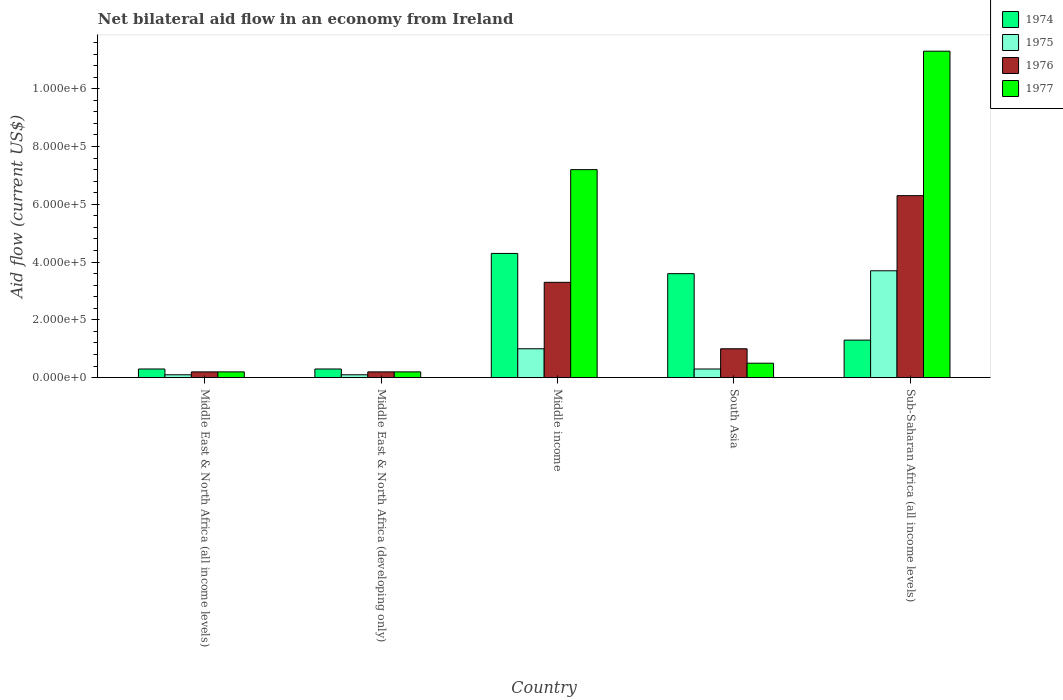How many groups of bars are there?
Your answer should be very brief. 5. How many bars are there on the 4th tick from the left?
Your answer should be very brief. 4. What is the label of the 3rd group of bars from the left?
Your response must be concise. Middle income. What is the net bilateral aid flow in 1977 in Middle East & North Africa (all income levels)?
Provide a succinct answer. 2.00e+04. Across all countries, what is the maximum net bilateral aid flow in 1976?
Offer a very short reply. 6.30e+05. In which country was the net bilateral aid flow in 1976 maximum?
Your answer should be very brief. Sub-Saharan Africa (all income levels). In which country was the net bilateral aid flow in 1975 minimum?
Provide a succinct answer. Middle East & North Africa (all income levels). What is the total net bilateral aid flow in 1974 in the graph?
Give a very brief answer. 9.80e+05. What is the difference between the net bilateral aid flow in 1975 in Middle East & North Africa (all income levels) and that in Middle East & North Africa (developing only)?
Make the answer very short. 0. What is the difference between the net bilateral aid flow in 1977 in Middle East & North Africa (all income levels) and the net bilateral aid flow in 1974 in Middle East & North Africa (developing only)?
Provide a short and direct response. -10000. What is the average net bilateral aid flow in 1974 per country?
Keep it short and to the point. 1.96e+05. What is the difference between the net bilateral aid flow of/in 1975 and net bilateral aid flow of/in 1976 in Middle East & North Africa (all income levels)?
Provide a short and direct response. -10000. In how many countries, is the net bilateral aid flow in 1975 greater than 1040000 US$?
Offer a terse response. 0. What is the ratio of the net bilateral aid flow in 1977 in Middle East & North Africa (all income levels) to that in Middle income?
Ensure brevity in your answer.  0.03. Is the net bilateral aid flow in 1976 in Middle East & North Africa (developing only) less than that in Middle income?
Offer a very short reply. Yes. Is the difference between the net bilateral aid flow in 1975 in South Asia and Sub-Saharan Africa (all income levels) greater than the difference between the net bilateral aid flow in 1976 in South Asia and Sub-Saharan Africa (all income levels)?
Keep it short and to the point. Yes. What is the difference between the highest and the second highest net bilateral aid flow in 1974?
Offer a very short reply. 7.00e+04. What does the 3rd bar from the left in Middle income represents?
Provide a succinct answer. 1976. What does the 3rd bar from the right in Middle East & North Africa (developing only) represents?
Give a very brief answer. 1975. Is it the case that in every country, the sum of the net bilateral aid flow in 1977 and net bilateral aid flow in 1976 is greater than the net bilateral aid flow in 1975?
Give a very brief answer. Yes. How many countries are there in the graph?
Ensure brevity in your answer.  5. What is the difference between two consecutive major ticks on the Y-axis?
Offer a very short reply. 2.00e+05. Does the graph contain any zero values?
Your response must be concise. No. Does the graph contain grids?
Ensure brevity in your answer.  No. How are the legend labels stacked?
Make the answer very short. Vertical. What is the title of the graph?
Offer a very short reply. Net bilateral aid flow in an economy from Ireland. Does "2010" appear as one of the legend labels in the graph?
Provide a short and direct response. No. What is the label or title of the X-axis?
Provide a short and direct response. Country. What is the Aid flow (current US$) in 1974 in Middle East & North Africa (all income levels)?
Provide a succinct answer. 3.00e+04. What is the Aid flow (current US$) in 1976 in Middle East & North Africa (all income levels)?
Offer a very short reply. 2.00e+04. What is the Aid flow (current US$) in 1974 in Middle East & North Africa (developing only)?
Give a very brief answer. 3.00e+04. What is the Aid flow (current US$) of 1976 in Middle East & North Africa (developing only)?
Provide a succinct answer. 2.00e+04. What is the Aid flow (current US$) in 1977 in Middle East & North Africa (developing only)?
Ensure brevity in your answer.  2.00e+04. What is the Aid flow (current US$) in 1975 in Middle income?
Offer a terse response. 1.00e+05. What is the Aid flow (current US$) of 1977 in Middle income?
Offer a terse response. 7.20e+05. What is the Aid flow (current US$) in 1974 in South Asia?
Offer a very short reply. 3.60e+05. What is the Aid flow (current US$) in 1975 in South Asia?
Keep it short and to the point. 3.00e+04. What is the Aid flow (current US$) in 1976 in South Asia?
Your response must be concise. 1.00e+05. What is the Aid flow (current US$) in 1974 in Sub-Saharan Africa (all income levels)?
Give a very brief answer. 1.30e+05. What is the Aid flow (current US$) of 1976 in Sub-Saharan Africa (all income levels)?
Offer a terse response. 6.30e+05. What is the Aid flow (current US$) of 1977 in Sub-Saharan Africa (all income levels)?
Make the answer very short. 1.13e+06. Across all countries, what is the maximum Aid flow (current US$) of 1974?
Ensure brevity in your answer.  4.30e+05. Across all countries, what is the maximum Aid flow (current US$) in 1975?
Your answer should be compact. 3.70e+05. Across all countries, what is the maximum Aid flow (current US$) of 1976?
Offer a terse response. 6.30e+05. Across all countries, what is the maximum Aid flow (current US$) of 1977?
Provide a succinct answer. 1.13e+06. Across all countries, what is the minimum Aid flow (current US$) in 1975?
Your response must be concise. 10000. Across all countries, what is the minimum Aid flow (current US$) in 1976?
Your answer should be compact. 2.00e+04. What is the total Aid flow (current US$) of 1974 in the graph?
Provide a short and direct response. 9.80e+05. What is the total Aid flow (current US$) of 1975 in the graph?
Give a very brief answer. 5.20e+05. What is the total Aid flow (current US$) of 1976 in the graph?
Keep it short and to the point. 1.10e+06. What is the total Aid flow (current US$) in 1977 in the graph?
Make the answer very short. 1.94e+06. What is the difference between the Aid flow (current US$) in 1974 in Middle East & North Africa (all income levels) and that in Middle East & North Africa (developing only)?
Your answer should be very brief. 0. What is the difference between the Aid flow (current US$) in 1975 in Middle East & North Africa (all income levels) and that in Middle East & North Africa (developing only)?
Your answer should be compact. 0. What is the difference between the Aid flow (current US$) of 1976 in Middle East & North Africa (all income levels) and that in Middle East & North Africa (developing only)?
Ensure brevity in your answer.  0. What is the difference between the Aid flow (current US$) of 1977 in Middle East & North Africa (all income levels) and that in Middle East & North Africa (developing only)?
Your response must be concise. 0. What is the difference between the Aid flow (current US$) of 1974 in Middle East & North Africa (all income levels) and that in Middle income?
Provide a short and direct response. -4.00e+05. What is the difference between the Aid flow (current US$) in 1976 in Middle East & North Africa (all income levels) and that in Middle income?
Keep it short and to the point. -3.10e+05. What is the difference between the Aid flow (current US$) in 1977 in Middle East & North Africa (all income levels) and that in Middle income?
Make the answer very short. -7.00e+05. What is the difference between the Aid flow (current US$) in 1974 in Middle East & North Africa (all income levels) and that in South Asia?
Provide a succinct answer. -3.30e+05. What is the difference between the Aid flow (current US$) of 1975 in Middle East & North Africa (all income levels) and that in South Asia?
Provide a succinct answer. -2.00e+04. What is the difference between the Aid flow (current US$) of 1974 in Middle East & North Africa (all income levels) and that in Sub-Saharan Africa (all income levels)?
Provide a short and direct response. -1.00e+05. What is the difference between the Aid flow (current US$) of 1975 in Middle East & North Africa (all income levels) and that in Sub-Saharan Africa (all income levels)?
Offer a terse response. -3.60e+05. What is the difference between the Aid flow (current US$) of 1976 in Middle East & North Africa (all income levels) and that in Sub-Saharan Africa (all income levels)?
Offer a very short reply. -6.10e+05. What is the difference between the Aid flow (current US$) of 1977 in Middle East & North Africa (all income levels) and that in Sub-Saharan Africa (all income levels)?
Provide a short and direct response. -1.11e+06. What is the difference between the Aid flow (current US$) of 1974 in Middle East & North Africa (developing only) and that in Middle income?
Provide a succinct answer. -4.00e+05. What is the difference between the Aid flow (current US$) in 1975 in Middle East & North Africa (developing only) and that in Middle income?
Your response must be concise. -9.00e+04. What is the difference between the Aid flow (current US$) in 1976 in Middle East & North Africa (developing only) and that in Middle income?
Provide a short and direct response. -3.10e+05. What is the difference between the Aid flow (current US$) in 1977 in Middle East & North Africa (developing only) and that in Middle income?
Offer a terse response. -7.00e+05. What is the difference between the Aid flow (current US$) in 1974 in Middle East & North Africa (developing only) and that in South Asia?
Give a very brief answer. -3.30e+05. What is the difference between the Aid flow (current US$) in 1976 in Middle East & North Africa (developing only) and that in South Asia?
Offer a very short reply. -8.00e+04. What is the difference between the Aid flow (current US$) of 1975 in Middle East & North Africa (developing only) and that in Sub-Saharan Africa (all income levels)?
Your answer should be very brief. -3.60e+05. What is the difference between the Aid flow (current US$) of 1976 in Middle East & North Africa (developing only) and that in Sub-Saharan Africa (all income levels)?
Give a very brief answer. -6.10e+05. What is the difference between the Aid flow (current US$) in 1977 in Middle East & North Africa (developing only) and that in Sub-Saharan Africa (all income levels)?
Provide a succinct answer. -1.11e+06. What is the difference between the Aid flow (current US$) of 1975 in Middle income and that in South Asia?
Make the answer very short. 7.00e+04. What is the difference between the Aid flow (current US$) of 1977 in Middle income and that in South Asia?
Ensure brevity in your answer.  6.70e+05. What is the difference between the Aid flow (current US$) in 1975 in Middle income and that in Sub-Saharan Africa (all income levels)?
Your answer should be very brief. -2.70e+05. What is the difference between the Aid flow (current US$) of 1977 in Middle income and that in Sub-Saharan Africa (all income levels)?
Your answer should be compact. -4.10e+05. What is the difference between the Aid flow (current US$) in 1976 in South Asia and that in Sub-Saharan Africa (all income levels)?
Keep it short and to the point. -5.30e+05. What is the difference between the Aid flow (current US$) in 1977 in South Asia and that in Sub-Saharan Africa (all income levels)?
Provide a short and direct response. -1.08e+06. What is the difference between the Aid flow (current US$) of 1974 in Middle East & North Africa (all income levels) and the Aid flow (current US$) of 1975 in Middle East & North Africa (developing only)?
Keep it short and to the point. 2.00e+04. What is the difference between the Aid flow (current US$) of 1976 in Middle East & North Africa (all income levels) and the Aid flow (current US$) of 1977 in Middle East & North Africa (developing only)?
Your answer should be compact. 0. What is the difference between the Aid flow (current US$) of 1974 in Middle East & North Africa (all income levels) and the Aid flow (current US$) of 1977 in Middle income?
Offer a terse response. -6.90e+05. What is the difference between the Aid flow (current US$) in 1975 in Middle East & North Africa (all income levels) and the Aid flow (current US$) in 1976 in Middle income?
Your answer should be very brief. -3.20e+05. What is the difference between the Aid flow (current US$) of 1975 in Middle East & North Africa (all income levels) and the Aid flow (current US$) of 1977 in Middle income?
Make the answer very short. -7.10e+05. What is the difference between the Aid flow (current US$) of 1976 in Middle East & North Africa (all income levels) and the Aid flow (current US$) of 1977 in Middle income?
Make the answer very short. -7.00e+05. What is the difference between the Aid flow (current US$) in 1974 in Middle East & North Africa (all income levels) and the Aid flow (current US$) in 1975 in South Asia?
Keep it short and to the point. 0. What is the difference between the Aid flow (current US$) in 1974 in Middle East & North Africa (all income levels) and the Aid flow (current US$) in 1976 in South Asia?
Ensure brevity in your answer.  -7.00e+04. What is the difference between the Aid flow (current US$) of 1974 in Middle East & North Africa (all income levels) and the Aid flow (current US$) of 1977 in South Asia?
Keep it short and to the point. -2.00e+04. What is the difference between the Aid flow (current US$) of 1975 in Middle East & North Africa (all income levels) and the Aid flow (current US$) of 1976 in South Asia?
Offer a terse response. -9.00e+04. What is the difference between the Aid flow (current US$) in 1974 in Middle East & North Africa (all income levels) and the Aid flow (current US$) in 1976 in Sub-Saharan Africa (all income levels)?
Provide a succinct answer. -6.00e+05. What is the difference between the Aid flow (current US$) of 1974 in Middle East & North Africa (all income levels) and the Aid flow (current US$) of 1977 in Sub-Saharan Africa (all income levels)?
Give a very brief answer. -1.10e+06. What is the difference between the Aid flow (current US$) of 1975 in Middle East & North Africa (all income levels) and the Aid flow (current US$) of 1976 in Sub-Saharan Africa (all income levels)?
Your response must be concise. -6.20e+05. What is the difference between the Aid flow (current US$) of 1975 in Middle East & North Africa (all income levels) and the Aid flow (current US$) of 1977 in Sub-Saharan Africa (all income levels)?
Make the answer very short. -1.12e+06. What is the difference between the Aid flow (current US$) of 1976 in Middle East & North Africa (all income levels) and the Aid flow (current US$) of 1977 in Sub-Saharan Africa (all income levels)?
Offer a terse response. -1.11e+06. What is the difference between the Aid flow (current US$) of 1974 in Middle East & North Africa (developing only) and the Aid flow (current US$) of 1975 in Middle income?
Provide a succinct answer. -7.00e+04. What is the difference between the Aid flow (current US$) of 1974 in Middle East & North Africa (developing only) and the Aid flow (current US$) of 1977 in Middle income?
Offer a very short reply. -6.90e+05. What is the difference between the Aid flow (current US$) in 1975 in Middle East & North Africa (developing only) and the Aid flow (current US$) in 1976 in Middle income?
Make the answer very short. -3.20e+05. What is the difference between the Aid flow (current US$) in 1975 in Middle East & North Africa (developing only) and the Aid flow (current US$) in 1977 in Middle income?
Provide a succinct answer. -7.10e+05. What is the difference between the Aid flow (current US$) in 1976 in Middle East & North Africa (developing only) and the Aid flow (current US$) in 1977 in Middle income?
Offer a terse response. -7.00e+05. What is the difference between the Aid flow (current US$) in 1974 in Middle East & North Africa (developing only) and the Aid flow (current US$) in 1975 in South Asia?
Provide a succinct answer. 0. What is the difference between the Aid flow (current US$) in 1975 in Middle East & North Africa (developing only) and the Aid flow (current US$) in 1977 in South Asia?
Offer a terse response. -4.00e+04. What is the difference between the Aid flow (current US$) in 1974 in Middle East & North Africa (developing only) and the Aid flow (current US$) in 1976 in Sub-Saharan Africa (all income levels)?
Your answer should be very brief. -6.00e+05. What is the difference between the Aid flow (current US$) in 1974 in Middle East & North Africa (developing only) and the Aid flow (current US$) in 1977 in Sub-Saharan Africa (all income levels)?
Make the answer very short. -1.10e+06. What is the difference between the Aid flow (current US$) in 1975 in Middle East & North Africa (developing only) and the Aid flow (current US$) in 1976 in Sub-Saharan Africa (all income levels)?
Keep it short and to the point. -6.20e+05. What is the difference between the Aid flow (current US$) in 1975 in Middle East & North Africa (developing only) and the Aid flow (current US$) in 1977 in Sub-Saharan Africa (all income levels)?
Provide a short and direct response. -1.12e+06. What is the difference between the Aid flow (current US$) in 1976 in Middle East & North Africa (developing only) and the Aid flow (current US$) in 1977 in Sub-Saharan Africa (all income levels)?
Give a very brief answer. -1.11e+06. What is the difference between the Aid flow (current US$) of 1975 in Middle income and the Aid flow (current US$) of 1976 in South Asia?
Offer a very short reply. 0. What is the difference between the Aid flow (current US$) in 1975 in Middle income and the Aid flow (current US$) in 1977 in South Asia?
Your answer should be compact. 5.00e+04. What is the difference between the Aid flow (current US$) of 1974 in Middle income and the Aid flow (current US$) of 1975 in Sub-Saharan Africa (all income levels)?
Provide a succinct answer. 6.00e+04. What is the difference between the Aid flow (current US$) of 1974 in Middle income and the Aid flow (current US$) of 1977 in Sub-Saharan Africa (all income levels)?
Provide a succinct answer. -7.00e+05. What is the difference between the Aid flow (current US$) in 1975 in Middle income and the Aid flow (current US$) in 1976 in Sub-Saharan Africa (all income levels)?
Your response must be concise. -5.30e+05. What is the difference between the Aid flow (current US$) in 1975 in Middle income and the Aid flow (current US$) in 1977 in Sub-Saharan Africa (all income levels)?
Ensure brevity in your answer.  -1.03e+06. What is the difference between the Aid flow (current US$) of 1976 in Middle income and the Aid flow (current US$) of 1977 in Sub-Saharan Africa (all income levels)?
Offer a very short reply. -8.00e+05. What is the difference between the Aid flow (current US$) in 1974 in South Asia and the Aid flow (current US$) in 1975 in Sub-Saharan Africa (all income levels)?
Make the answer very short. -10000. What is the difference between the Aid flow (current US$) of 1974 in South Asia and the Aid flow (current US$) of 1976 in Sub-Saharan Africa (all income levels)?
Make the answer very short. -2.70e+05. What is the difference between the Aid flow (current US$) of 1974 in South Asia and the Aid flow (current US$) of 1977 in Sub-Saharan Africa (all income levels)?
Give a very brief answer. -7.70e+05. What is the difference between the Aid flow (current US$) in 1975 in South Asia and the Aid flow (current US$) in 1976 in Sub-Saharan Africa (all income levels)?
Ensure brevity in your answer.  -6.00e+05. What is the difference between the Aid flow (current US$) in 1975 in South Asia and the Aid flow (current US$) in 1977 in Sub-Saharan Africa (all income levels)?
Offer a terse response. -1.10e+06. What is the difference between the Aid flow (current US$) of 1976 in South Asia and the Aid flow (current US$) of 1977 in Sub-Saharan Africa (all income levels)?
Make the answer very short. -1.03e+06. What is the average Aid flow (current US$) of 1974 per country?
Your response must be concise. 1.96e+05. What is the average Aid flow (current US$) in 1975 per country?
Your answer should be very brief. 1.04e+05. What is the average Aid flow (current US$) in 1977 per country?
Give a very brief answer. 3.88e+05. What is the difference between the Aid flow (current US$) of 1975 and Aid flow (current US$) of 1976 in Middle East & North Africa (all income levels)?
Your response must be concise. -10000. What is the difference between the Aid flow (current US$) of 1975 and Aid flow (current US$) of 1977 in Middle East & North Africa (all income levels)?
Provide a succinct answer. -10000. What is the difference between the Aid flow (current US$) in 1974 and Aid flow (current US$) in 1976 in Middle East & North Africa (developing only)?
Keep it short and to the point. 10000. What is the difference between the Aid flow (current US$) of 1975 and Aid flow (current US$) of 1977 in Middle East & North Africa (developing only)?
Provide a succinct answer. -10000. What is the difference between the Aid flow (current US$) of 1976 and Aid flow (current US$) of 1977 in Middle East & North Africa (developing only)?
Your answer should be compact. 0. What is the difference between the Aid flow (current US$) in 1974 and Aid flow (current US$) in 1976 in Middle income?
Provide a succinct answer. 1.00e+05. What is the difference between the Aid flow (current US$) of 1975 and Aid flow (current US$) of 1976 in Middle income?
Keep it short and to the point. -2.30e+05. What is the difference between the Aid flow (current US$) in 1975 and Aid flow (current US$) in 1977 in Middle income?
Keep it short and to the point. -6.20e+05. What is the difference between the Aid flow (current US$) in 1976 and Aid flow (current US$) in 1977 in Middle income?
Offer a terse response. -3.90e+05. What is the difference between the Aid flow (current US$) in 1974 and Aid flow (current US$) in 1976 in South Asia?
Offer a very short reply. 2.60e+05. What is the difference between the Aid flow (current US$) in 1974 and Aid flow (current US$) in 1977 in South Asia?
Ensure brevity in your answer.  3.10e+05. What is the difference between the Aid flow (current US$) in 1974 and Aid flow (current US$) in 1976 in Sub-Saharan Africa (all income levels)?
Your answer should be compact. -5.00e+05. What is the difference between the Aid flow (current US$) of 1975 and Aid flow (current US$) of 1976 in Sub-Saharan Africa (all income levels)?
Your answer should be very brief. -2.60e+05. What is the difference between the Aid flow (current US$) of 1975 and Aid flow (current US$) of 1977 in Sub-Saharan Africa (all income levels)?
Provide a short and direct response. -7.60e+05. What is the difference between the Aid flow (current US$) in 1976 and Aid flow (current US$) in 1977 in Sub-Saharan Africa (all income levels)?
Offer a terse response. -5.00e+05. What is the ratio of the Aid flow (current US$) of 1974 in Middle East & North Africa (all income levels) to that in Middle East & North Africa (developing only)?
Your response must be concise. 1. What is the ratio of the Aid flow (current US$) in 1975 in Middle East & North Africa (all income levels) to that in Middle East & North Africa (developing only)?
Offer a terse response. 1. What is the ratio of the Aid flow (current US$) in 1976 in Middle East & North Africa (all income levels) to that in Middle East & North Africa (developing only)?
Offer a very short reply. 1. What is the ratio of the Aid flow (current US$) in 1977 in Middle East & North Africa (all income levels) to that in Middle East & North Africa (developing only)?
Offer a very short reply. 1. What is the ratio of the Aid flow (current US$) of 1974 in Middle East & North Africa (all income levels) to that in Middle income?
Provide a succinct answer. 0.07. What is the ratio of the Aid flow (current US$) in 1975 in Middle East & North Africa (all income levels) to that in Middle income?
Keep it short and to the point. 0.1. What is the ratio of the Aid flow (current US$) of 1976 in Middle East & North Africa (all income levels) to that in Middle income?
Your answer should be compact. 0.06. What is the ratio of the Aid flow (current US$) of 1977 in Middle East & North Africa (all income levels) to that in Middle income?
Provide a short and direct response. 0.03. What is the ratio of the Aid flow (current US$) in 1974 in Middle East & North Africa (all income levels) to that in South Asia?
Provide a succinct answer. 0.08. What is the ratio of the Aid flow (current US$) of 1974 in Middle East & North Africa (all income levels) to that in Sub-Saharan Africa (all income levels)?
Offer a very short reply. 0.23. What is the ratio of the Aid flow (current US$) in 1975 in Middle East & North Africa (all income levels) to that in Sub-Saharan Africa (all income levels)?
Offer a terse response. 0.03. What is the ratio of the Aid flow (current US$) of 1976 in Middle East & North Africa (all income levels) to that in Sub-Saharan Africa (all income levels)?
Offer a terse response. 0.03. What is the ratio of the Aid flow (current US$) in 1977 in Middle East & North Africa (all income levels) to that in Sub-Saharan Africa (all income levels)?
Ensure brevity in your answer.  0.02. What is the ratio of the Aid flow (current US$) of 1974 in Middle East & North Africa (developing only) to that in Middle income?
Your response must be concise. 0.07. What is the ratio of the Aid flow (current US$) of 1976 in Middle East & North Africa (developing only) to that in Middle income?
Provide a short and direct response. 0.06. What is the ratio of the Aid flow (current US$) of 1977 in Middle East & North Africa (developing only) to that in Middle income?
Give a very brief answer. 0.03. What is the ratio of the Aid flow (current US$) of 1974 in Middle East & North Africa (developing only) to that in South Asia?
Your answer should be compact. 0.08. What is the ratio of the Aid flow (current US$) in 1975 in Middle East & North Africa (developing only) to that in South Asia?
Provide a short and direct response. 0.33. What is the ratio of the Aid flow (current US$) in 1976 in Middle East & North Africa (developing only) to that in South Asia?
Make the answer very short. 0.2. What is the ratio of the Aid flow (current US$) of 1977 in Middle East & North Africa (developing only) to that in South Asia?
Provide a succinct answer. 0.4. What is the ratio of the Aid flow (current US$) of 1974 in Middle East & North Africa (developing only) to that in Sub-Saharan Africa (all income levels)?
Your answer should be very brief. 0.23. What is the ratio of the Aid flow (current US$) of 1975 in Middle East & North Africa (developing only) to that in Sub-Saharan Africa (all income levels)?
Keep it short and to the point. 0.03. What is the ratio of the Aid flow (current US$) of 1976 in Middle East & North Africa (developing only) to that in Sub-Saharan Africa (all income levels)?
Provide a succinct answer. 0.03. What is the ratio of the Aid flow (current US$) in 1977 in Middle East & North Africa (developing only) to that in Sub-Saharan Africa (all income levels)?
Offer a terse response. 0.02. What is the ratio of the Aid flow (current US$) in 1974 in Middle income to that in South Asia?
Offer a very short reply. 1.19. What is the ratio of the Aid flow (current US$) in 1975 in Middle income to that in South Asia?
Your response must be concise. 3.33. What is the ratio of the Aid flow (current US$) of 1977 in Middle income to that in South Asia?
Offer a terse response. 14.4. What is the ratio of the Aid flow (current US$) of 1974 in Middle income to that in Sub-Saharan Africa (all income levels)?
Give a very brief answer. 3.31. What is the ratio of the Aid flow (current US$) of 1975 in Middle income to that in Sub-Saharan Africa (all income levels)?
Your response must be concise. 0.27. What is the ratio of the Aid flow (current US$) in 1976 in Middle income to that in Sub-Saharan Africa (all income levels)?
Your answer should be very brief. 0.52. What is the ratio of the Aid flow (current US$) of 1977 in Middle income to that in Sub-Saharan Africa (all income levels)?
Provide a short and direct response. 0.64. What is the ratio of the Aid flow (current US$) of 1974 in South Asia to that in Sub-Saharan Africa (all income levels)?
Your answer should be very brief. 2.77. What is the ratio of the Aid flow (current US$) of 1975 in South Asia to that in Sub-Saharan Africa (all income levels)?
Your response must be concise. 0.08. What is the ratio of the Aid flow (current US$) in 1976 in South Asia to that in Sub-Saharan Africa (all income levels)?
Provide a succinct answer. 0.16. What is the ratio of the Aid flow (current US$) of 1977 in South Asia to that in Sub-Saharan Africa (all income levels)?
Your answer should be very brief. 0.04. What is the difference between the highest and the second highest Aid flow (current US$) of 1975?
Give a very brief answer. 2.70e+05. What is the difference between the highest and the lowest Aid flow (current US$) in 1974?
Your answer should be compact. 4.00e+05. What is the difference between the highest and the lowest Aid flow (current US$) in 1975?
Ensure brevity in your answer.  3.60e+05. What is the difference between the highest and the lowest Aid flow (current US$) of 1977?
Give a very brief answer. 1.11e+06. 